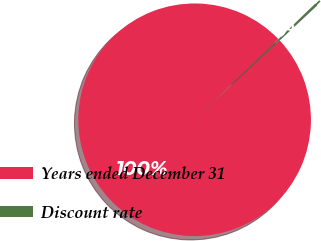<chart> <loc_0><loc_0><loc_500><loc_500><pie_chart><fcel>Years ended December 31<fcel>Discount rate<nl><fcel>99.75%<fcel>0.25%<nl></chart> 